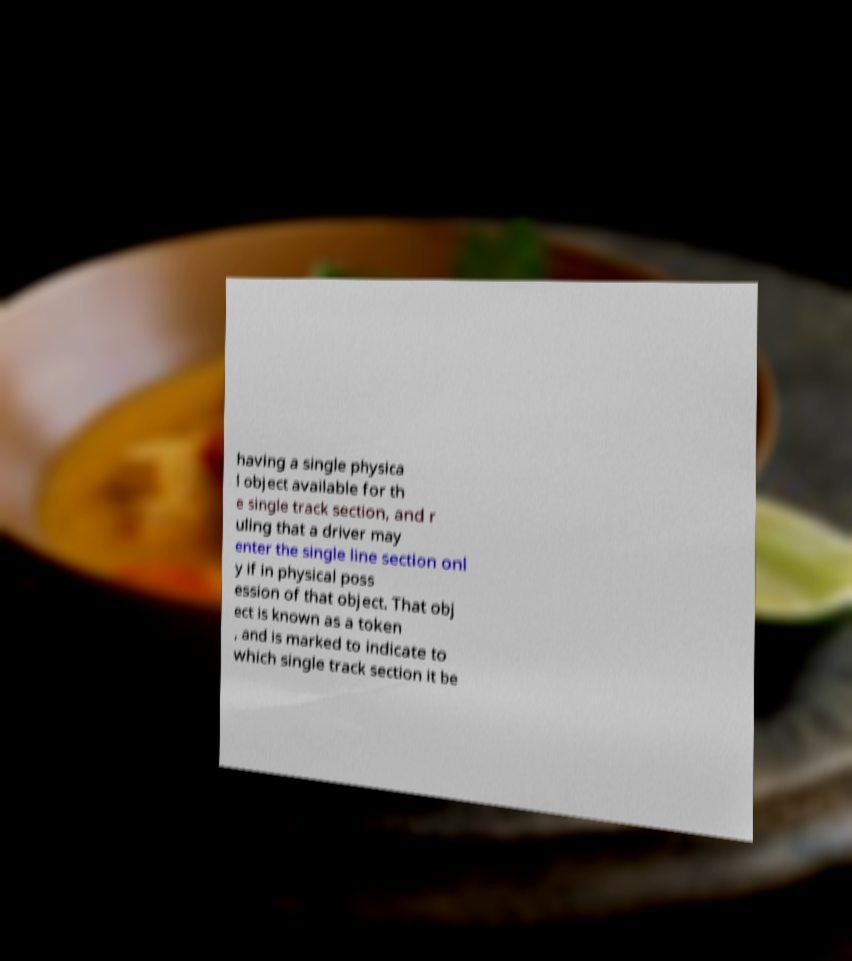I need the written content from this picture converted into text. Can you do that? having a single physica l object available for th e single track section, and r uling that a driver may enter the single line section onl y if in physical poss ession of that object. That obj ect is known as a token , and is marked to indicate to which single track section it be 